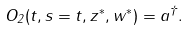Convert formula to latex. <formula><loc_0><loc_0><loc_500><loc_500>O _ { 2 } ( t , s = t , z ^ { * } , w ^ { * } ) = a ^ { \dag } .</formula> 